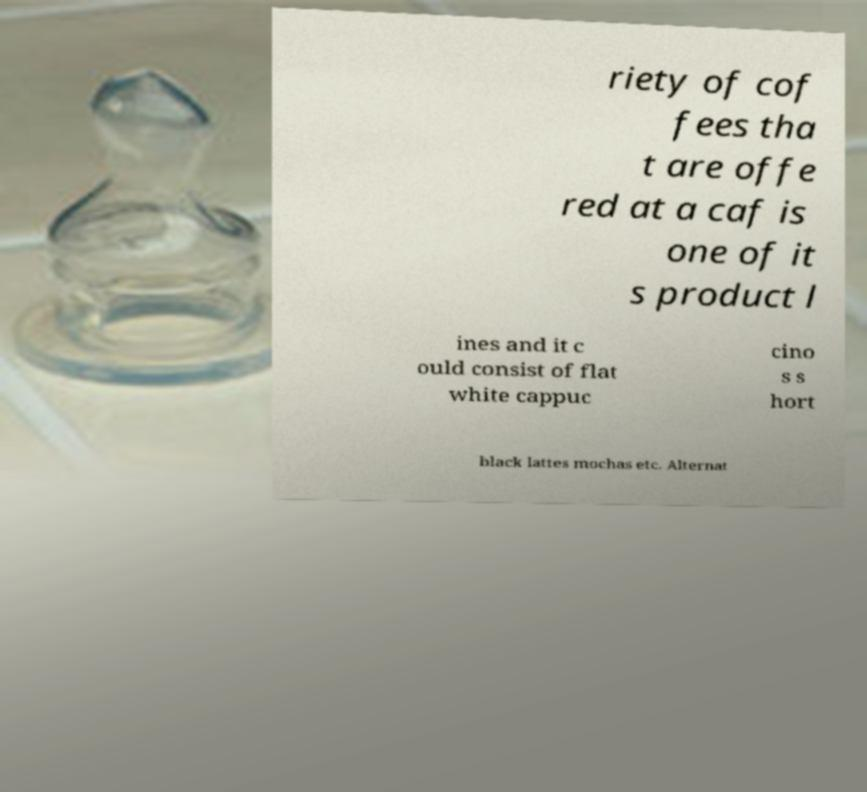Could you assist in decoding the text presented in this image and type it out clearly? riety of cof fees tha t are offe red at a caf is one of it s product l ines and it c ould consist of flat white cappuc cino s s hort black lattes mochas etc. Alternat 